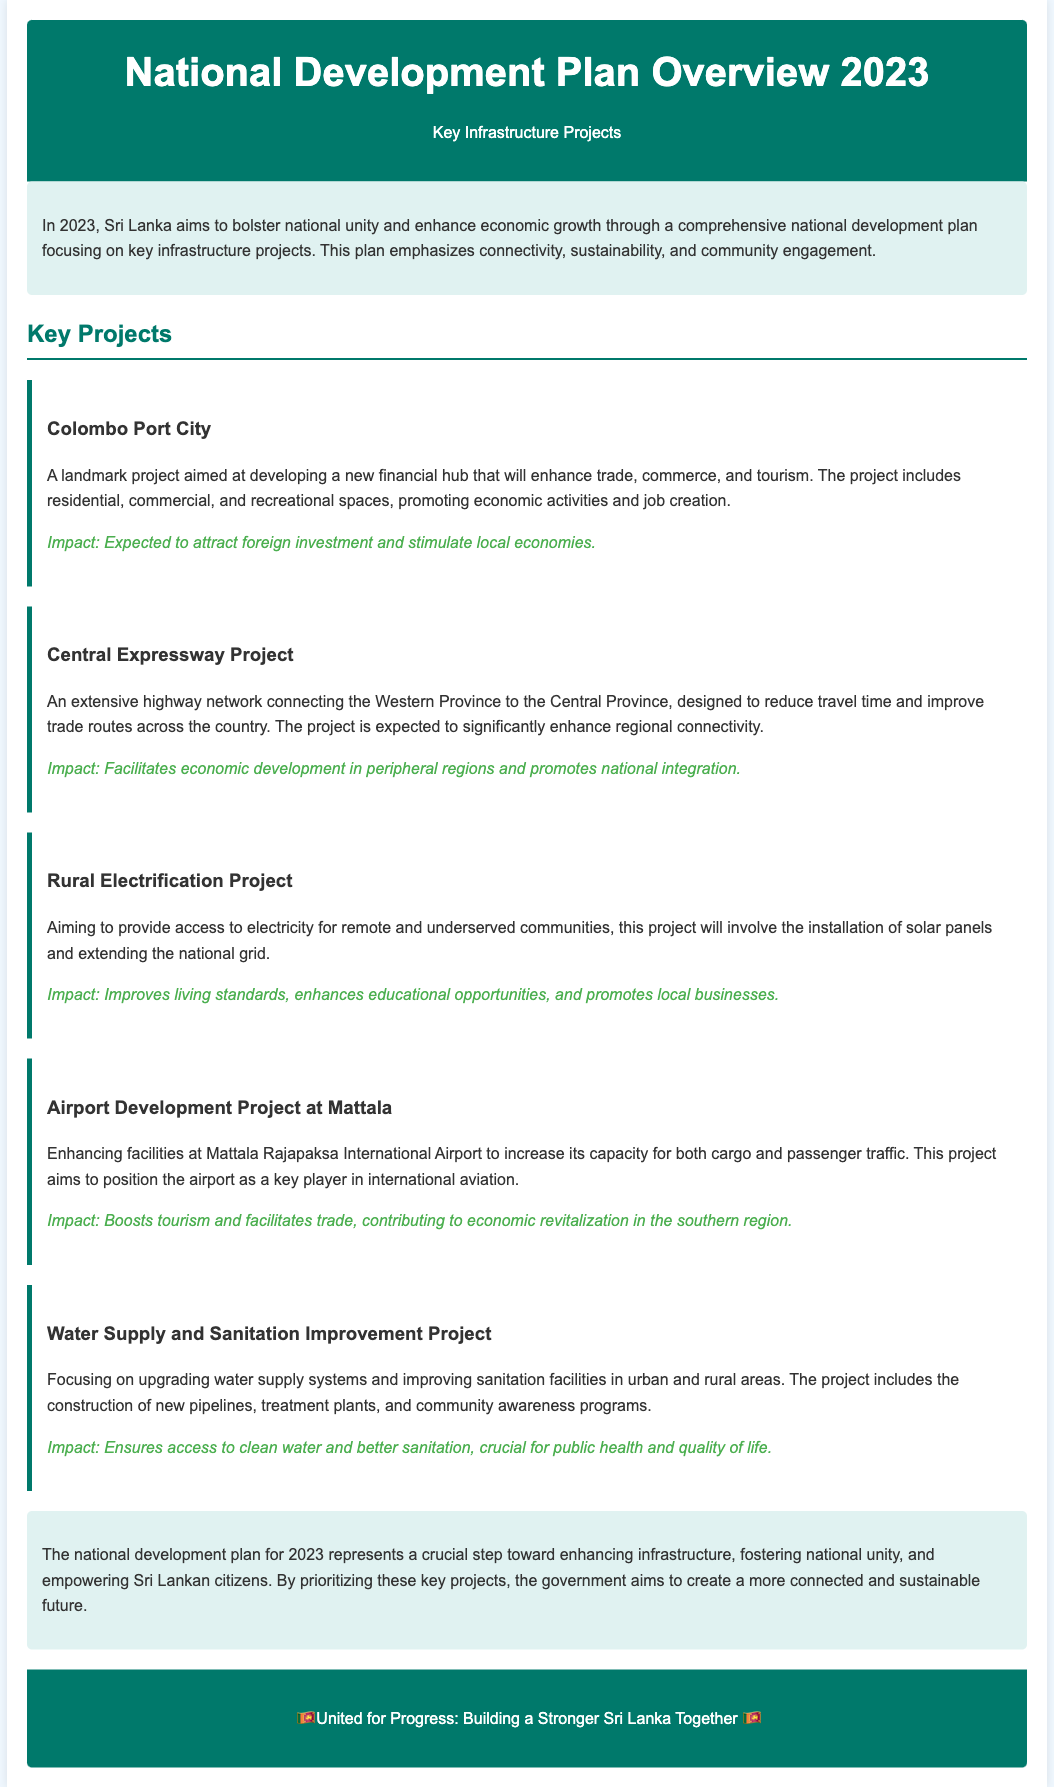What is the main goal of the national development plan for 2023? The main goal is to bolster national unity and enhance economic growth through key infrastructure projects.
Answer: Economic growth What is the name of the project aimed at developing a financial hub? The project focuses on creating a new financial hub that will enhance trade, commerce, and tourism.
Answer: Colombo Port City Which project is designed to reduce travel time between provinces? This project is expected to significantly enhance regional connectivity and improve trade routes across the country.
Answer: Central Expressway Project What infrastructure improvement is aimed at remote communities? This project provides access to electricity through the installation of solar panels and extension of the national grid.
Answer: Rural Electrification Project Which project aims to enhance the capacity of an airport? The goal of this project is to position the airport as a key player in international aviation.
Answer: Airport Development Project at Mattala What aspect of public health does the Water Supply and Sanitation Improvement Project address? This project ensures access to clean water and better sanitation, which is crucial for public health and quality of life.
Answer: Public health What impact does the Rural Electrification Project have on education? The project improves living standards, which enhances educational opportunities.
Answer: Enhances educational opportunities Which infrastructure project promotes tourism in the southern region? This project aims to boost tourism and facilitate trade in the southern region by enhancing airport facilities.
Answer: Airport Development Project at Mattala 